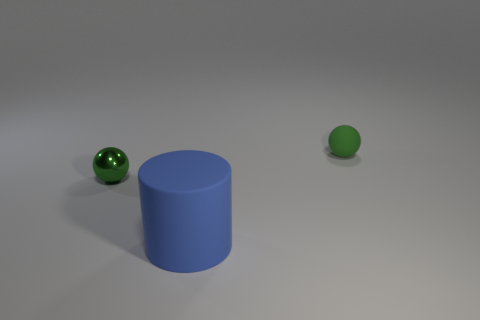Add 1 tiny balls. How many objects exist? 4 Subtract all cylinders. How many objects are left? 2 Subtract all big blue blocks. Subtract all green things. How many objects are left? 1 Add 2 big blue cylinders. How many big blue cylinders are left? 3 Add 1 matte balls. How many matte balls exist? 2 Subtract 0 gray spheres. How many objects are left? 3 